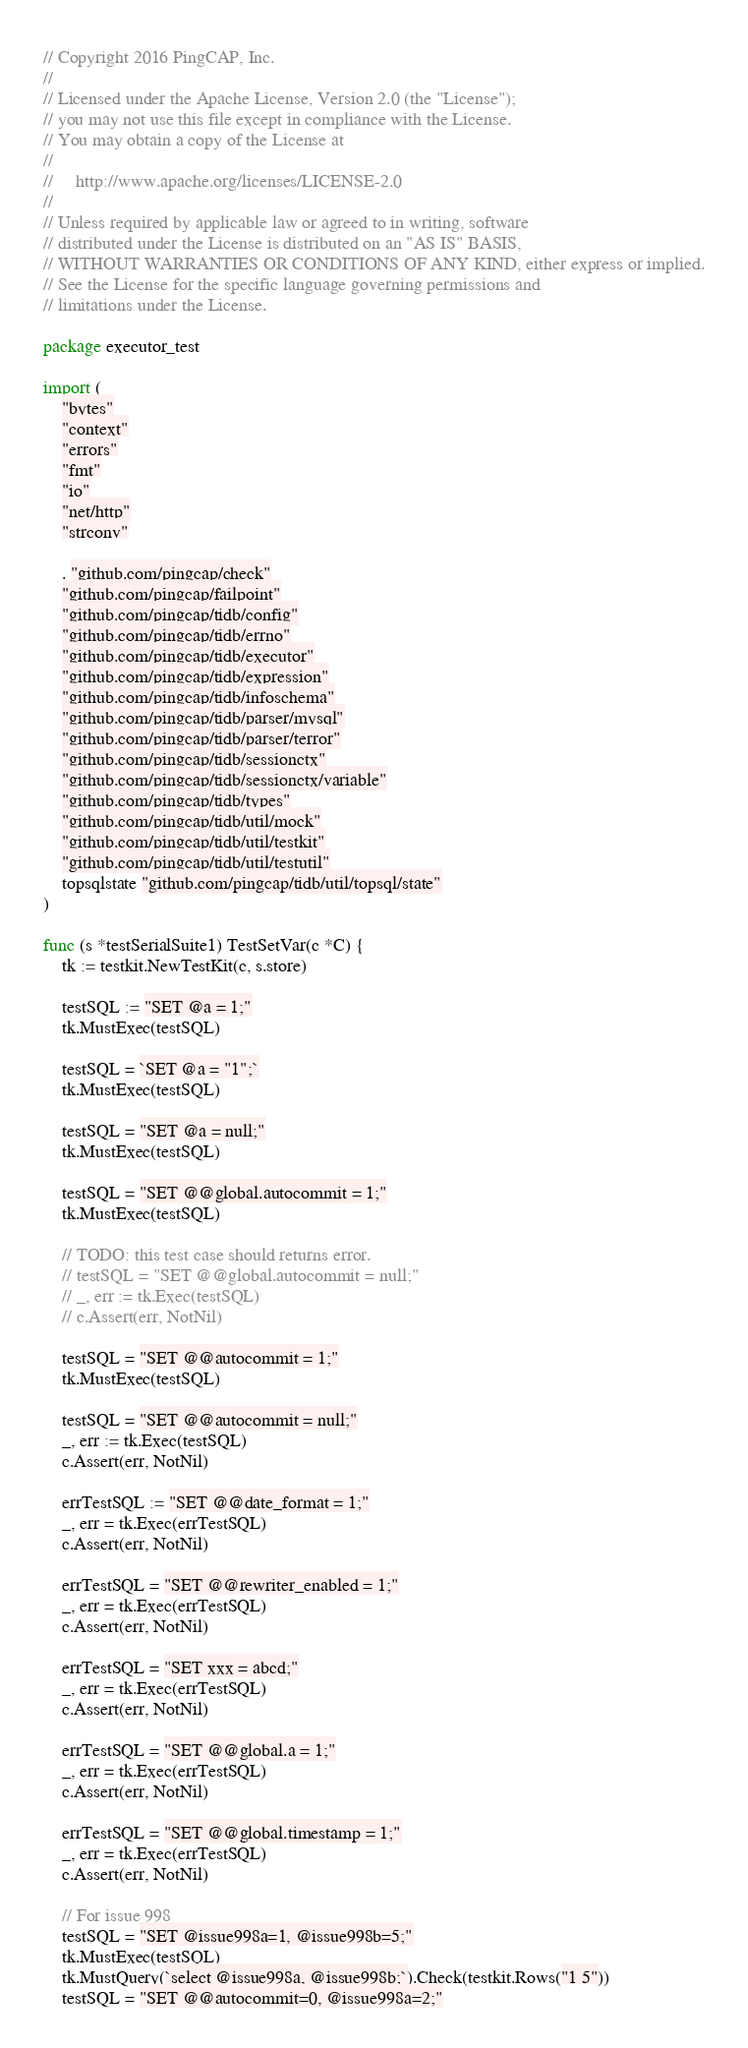Convert code to text. <code><loc_0><loc_0><loc_500><loc_500><_Go_>// Copyright 2016 PingCAP, Inc.
//
// Licensed under the Apache License, Version 2.0 (the "License");
// you may not use this file except in compliance with the License.
// You may obtain a copy of the License at
//
//     http://www.apache.org/licenses/LICENSE-2.0
//
// Unless required by applicable law or agreed to in writing, software
// distributed under the License is distributed on an "AS IS" BASIS,
// WITHOUT WARRANTIES OR CONDITIONS OF ANY KIND, either express or implied.
// See the License for the specific language governing permissions and
// limitations under the License.

package executor_test

import (
	"bytes"
	"context"
	"errors"
	"fmt"
	"io"
	"net/http"
	"strconv"

	. "github.com/pingcap/check"
	"github.com/pingcap/failpoint"
	"github.com/pingcap/tidb/config"
	"github.com/pingcap/tidb/errno"
	"github.com/pingcap/tidb/executor"
	"github.com/pingcap/tidb/expression"
	"github.com/pingcap/tidb/infoschema"
	"github.com/pingcap/tidb/parser/mysql"
	"github.com/pingcap/tidb/parser/terror"
	"github.com/pingcap/tidb/sessionctx"
	"github.com/pingcap/tidb/sessionctx/variable"
	"github.com/pingcap/tidb/types"
	"github.com/pingcap/tidb/util/mock"
	"github.com/pingcap/tidb/util/testkit"
	"github.com/pingcap/tidb/util/testutil"
	topsqlstate "github.com/pingcap/tidb/util/topsql/state"
)

func (s *testSerialSuite1) TestSetVar(c *C) {
	tk := testkit.NewTestKit(c, s.store)

	testSQL := "SET @a = 1;"
	tk.MustExec(testSQL)

	testSQL = `SET @a = "1";`
	tk.MustExec(testSQL)

	testSQL = "SET @a = null;"
	tk.MustExec(testSQL)

	testSQL = "SET @@global.autocommit = 1;"
	tk.MustExec(testSQL)

	// TODO: this test case should returns error.
	// testSQL = "SET @@global.autocommit = null;"
	// _, err := tk.Exec(testSQL)
	// c.Assert(err, NotNil)

	testSQL = "SET @@autocommit = 1;"
	tk.MustExec(testSQL)

	testSQL = "SET @@autocommit = null;"
	_, err := tk.Exec(testSQL)
	c.Assert(err, NotNil)

	errTestSQL := "SET @@date_format = 1;"
	_, err = tk.Exec(errTestSQL)
	c.Assert(err, NotNil)

	errTestSQL = "SET @@rewriter_enabled = 1;"
	_, err = tk.Exec(errTestSQL)
	c.Assert(err, NotNil)

	errTestSQL = "SET xxx = abcd;"
	_, err = tk.Exec(errTestSQL)
	c.Assert(err, NotNil)

	errTestSQL = "SET @@global.a = 1;"
	_, err = tk.Exec(errTestSQL)
	c.Assert(err, NotNil)

	errTestSQL = "SET @@global.timestamp = 1;"
	_, err = tk.Exec(errTestSQL)
	c.Assert(err, NotNil)

	// For issue 998
	testSQL = "SET @issue998a=1, @issue998b=5;"
	tk.MustExec(testSQL)
	tk.MustQuery(`select @issue998a, @issue998b;`).Check(testkit.Rows("1 5"))
	testSQL = "SET @@autocommit=0, @issue998a=2;"</code> 